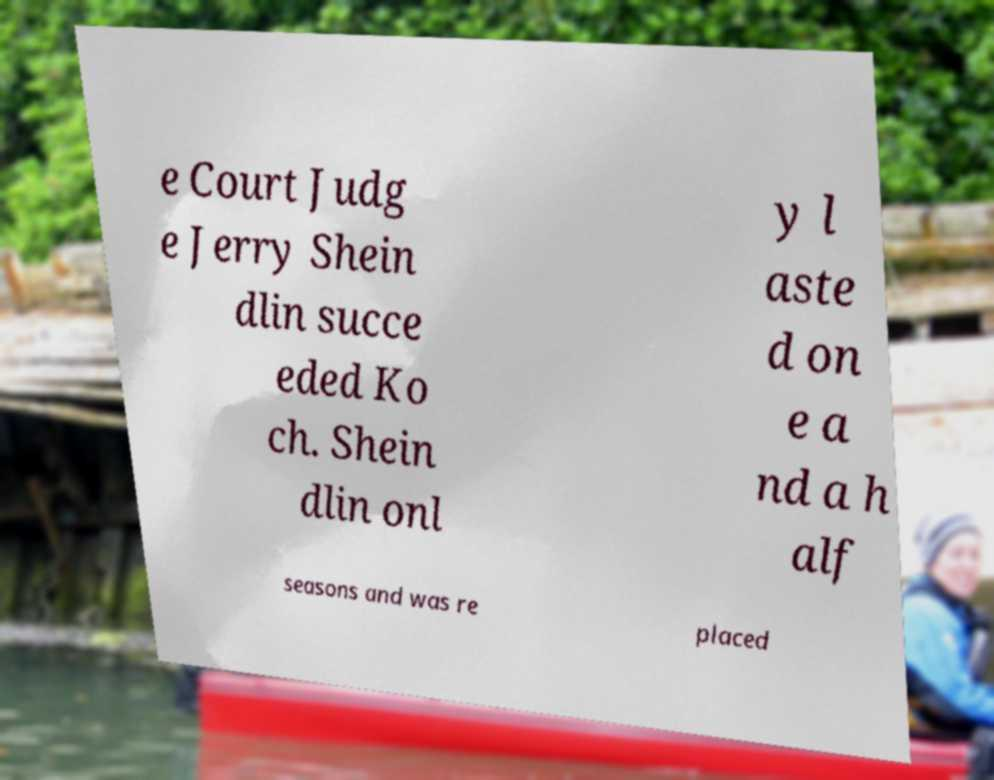Can you read and provide the text displayed in the image?This photo seems to have some interesting text. Can you extract and type it out for me? e Court Judg e Jerry Shein dlin succe eded Ko ch. Shein dlin onl y l aste d on e a nd a h alf seasons and was re placed 